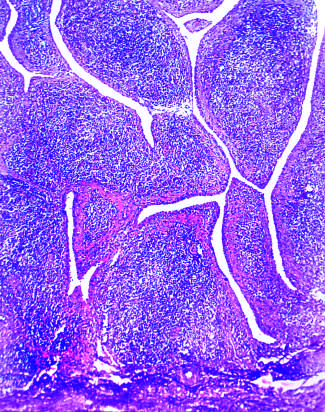how does low magnification show marked synovial hypertrophy?
Answer the question using a single word or phrase. With formation of villi 